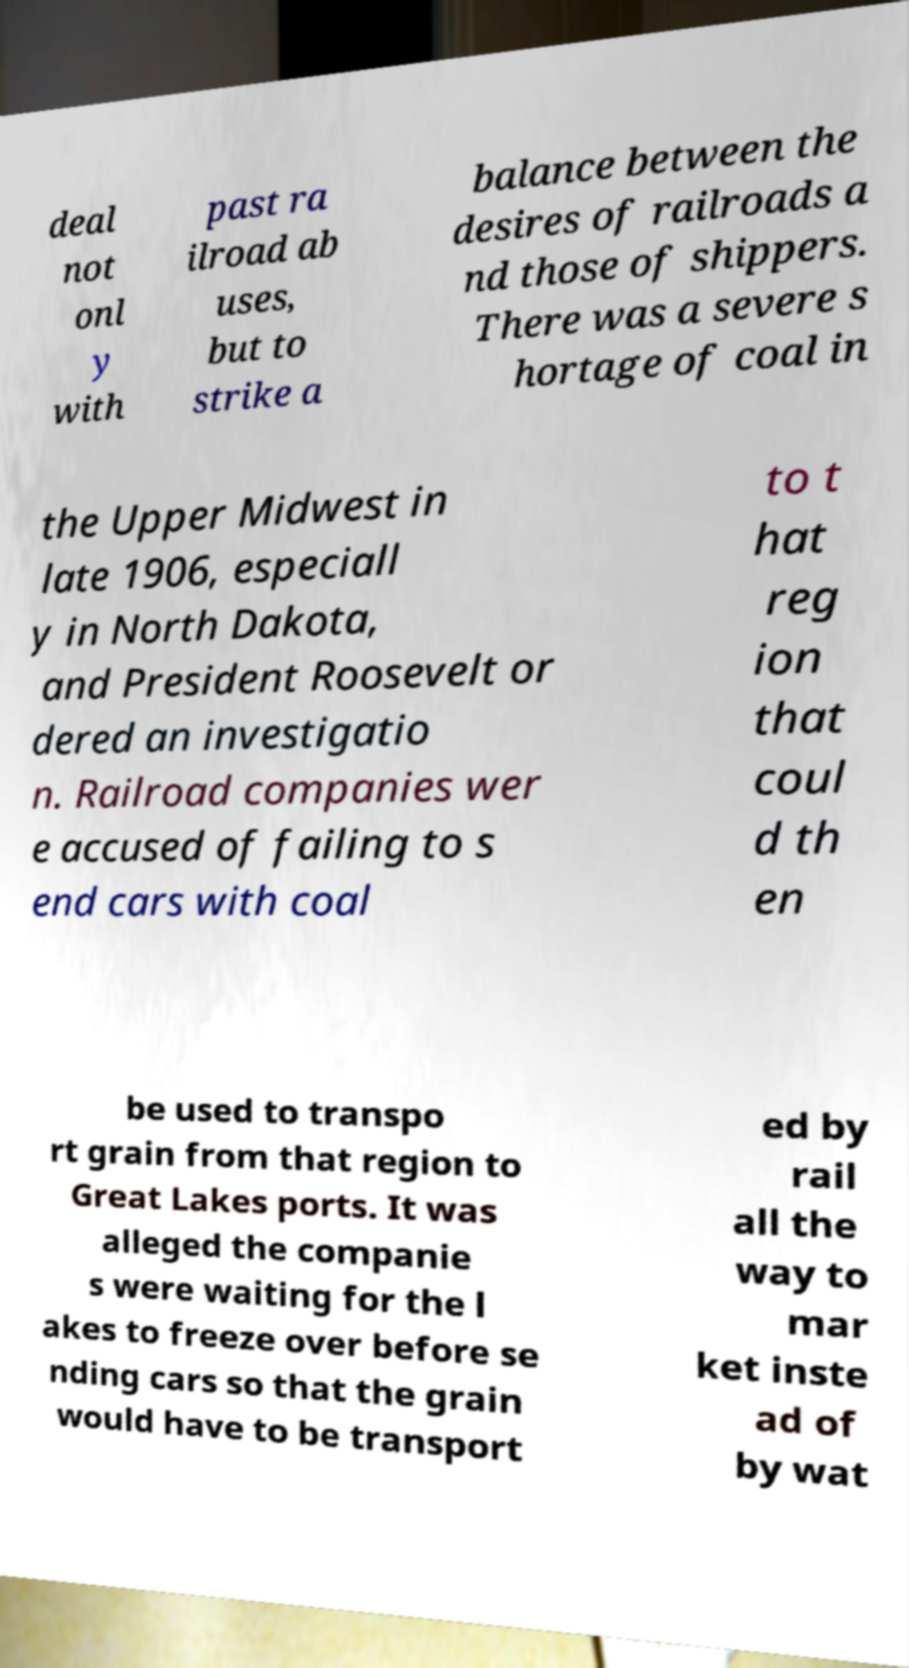I need the written content from this picture converted into text. Can you do that? deal not onl y with past ra ilroad ab uses, but to strike a balance between the desires of railroads a nd those of shippers. There was a severe s hortage of coal in the Upper Midwest in late 1906, especiall y in North Dakota, and President Roosevelt or dered an investigatio n. Railroad companies wer e accused of failing to s end cars with coal to t hat reg ion that coul d th en be used to transpo rt grain from that region to Great Lakes ports. It was alleged the companie s were waiting for the l akes to freeze over before se nding cars so that the grain would have to be transport ed by rail all the way to mar ket inste ad of by wat 